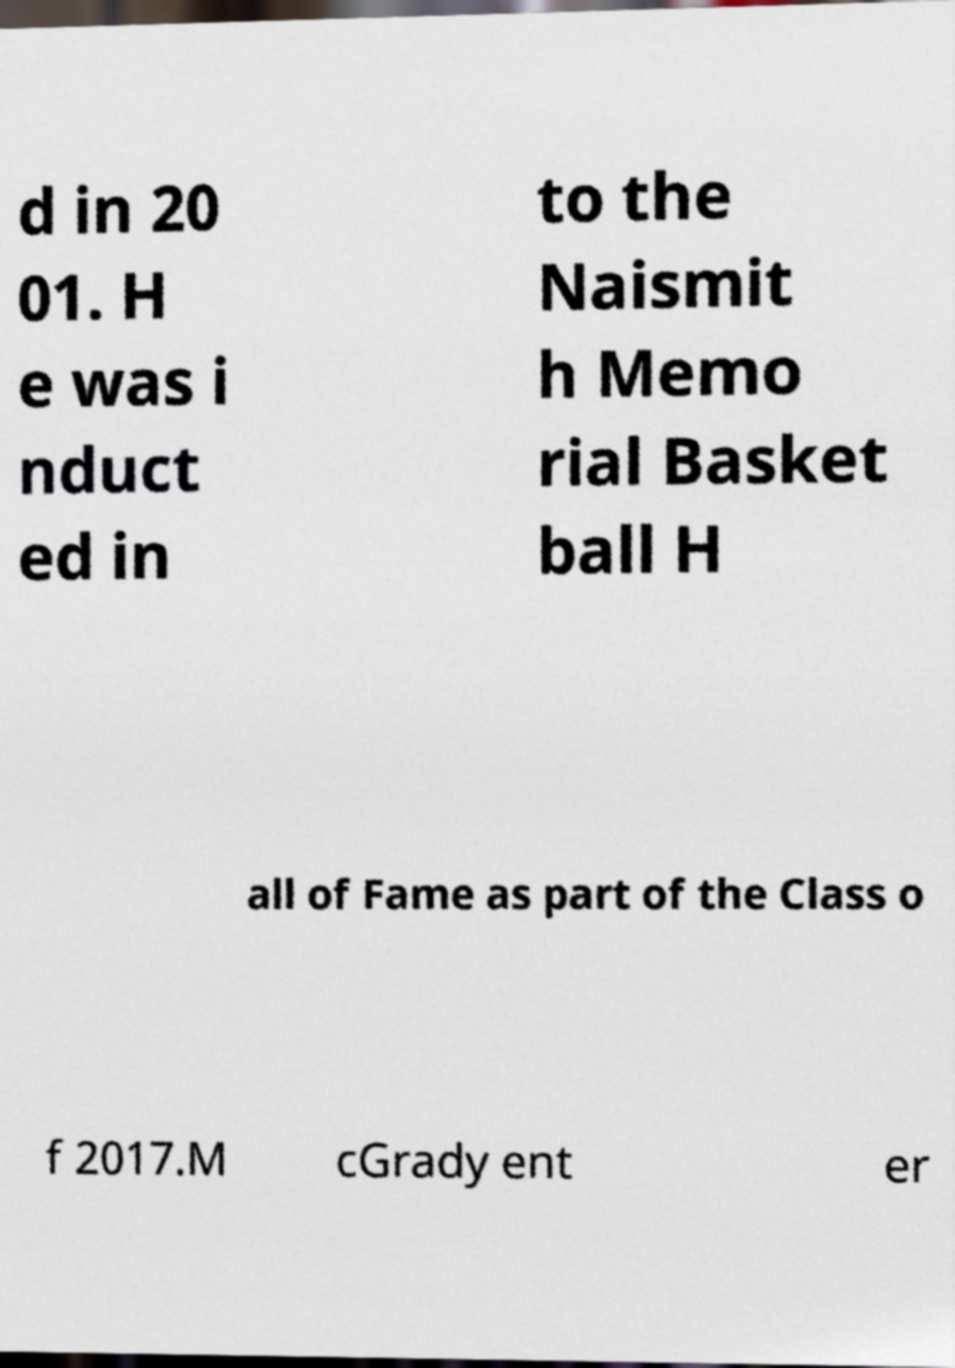Could you assist in decoding the text presented in this image and type it out clearly? d in 20 01. H e was i nduct ed in to the Naismit h Memo rial Basket ball H all of Fame as part of the Class o f 2017.M cGrady ent er 